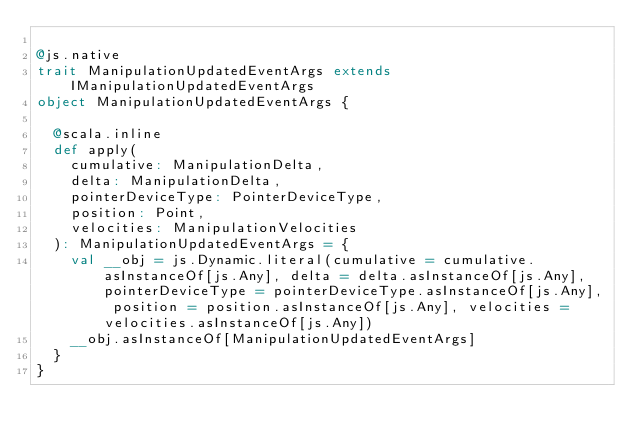Convert code to text. <code><loc_0><loc_0><loc_500><loc_500><_Scala_>
@js.native
trait ManipulationUpdatedEventArgs extends IManipulationUpdatedEventArgs
object ManipulationUpdatedEventArgs {
  
  @scala.inline
  def apply(
    cumulative: ManipulationDelta,
    delta: ManipulationDelta,
    pointerDeviceType: PointerDeviceType,
    position: Point,
    velocities: ManipulationVelocities
  ): ManipulationUpdatedEventArgs = {
    val __obj = js.Dynamic.literal(cumulative = cumulative.asInstanceOf[js.Any], delta = delta.asInstanceOf[js.Any], pointerDeviceType = pointerDeviceType.asInstanceOf[js.Any], position = position.asInstanceOf[js.Any], velocities = velocities.asInstanceOf[js.Any])
    __obj.asInstanceOf[ManipulationUpdatedEventArgs]
  }
}
</code> 